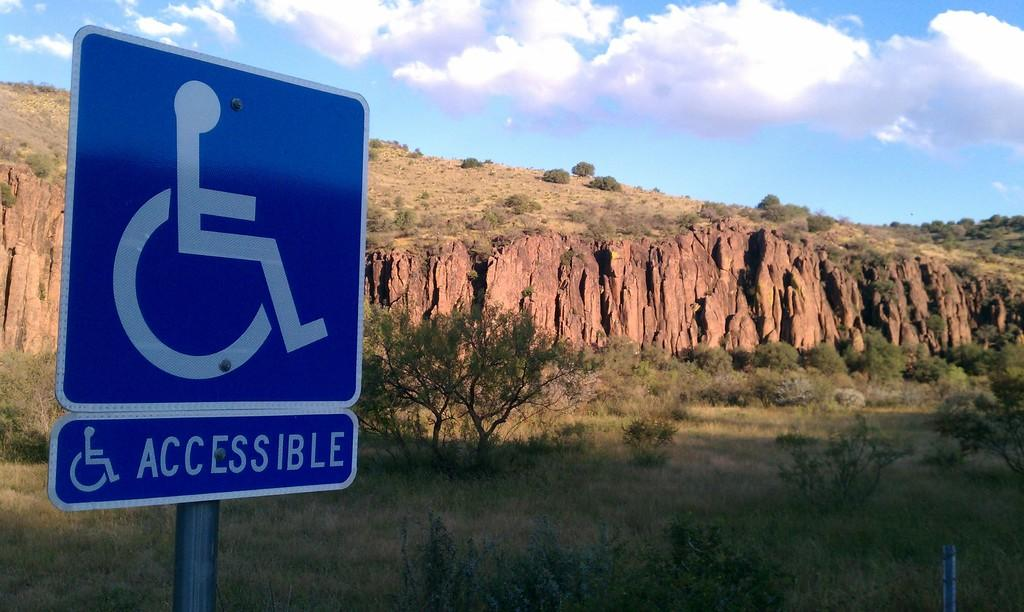Provide a one-sentence caption for the provided image. accessible sign on the side of the road with cliffs near by. 